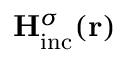Convert formula to latex. <formula><loc_0><loc_0><loc_500><loc_500>{ { H } _ { i n c } ^ { \sigma } } ( { r } )</formula> 